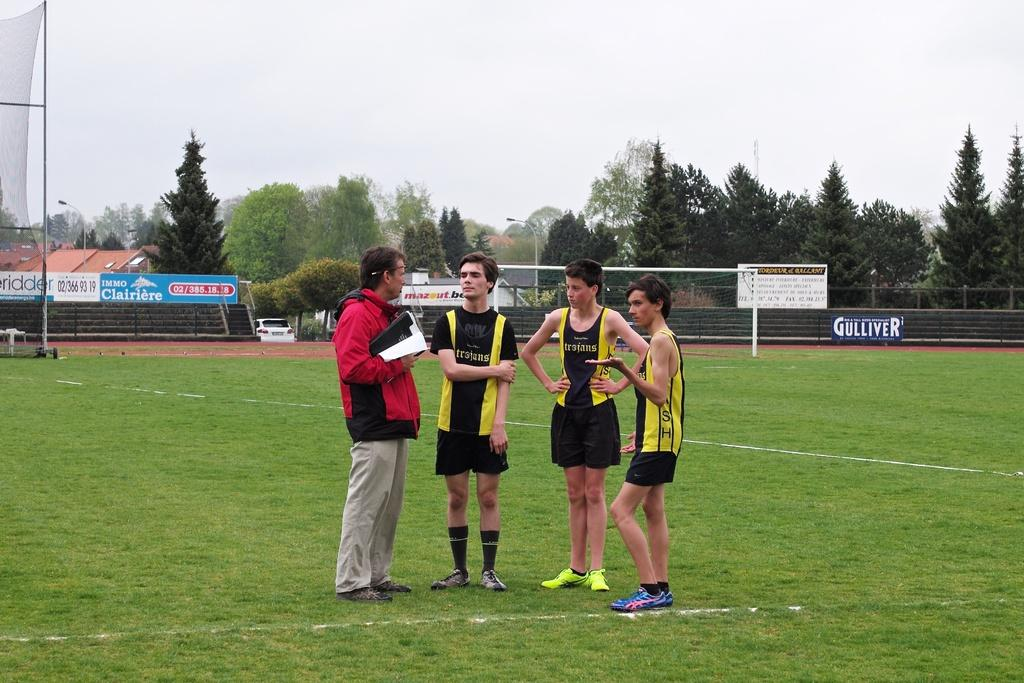<image>
Describe the image concisely. Four players standing on a field with jerseys that says Trojans. 